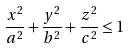<formula> <loc_0><loc_0><loc_500><loc_500>\frac { x ^ { 2 } } { a ^ { 2 } } + \frac { y ^ { 2 } } { b ^ { 2 } } + \frac { z ^ { 2 } } { c ^ { 2 } } \leq 1</formula> 